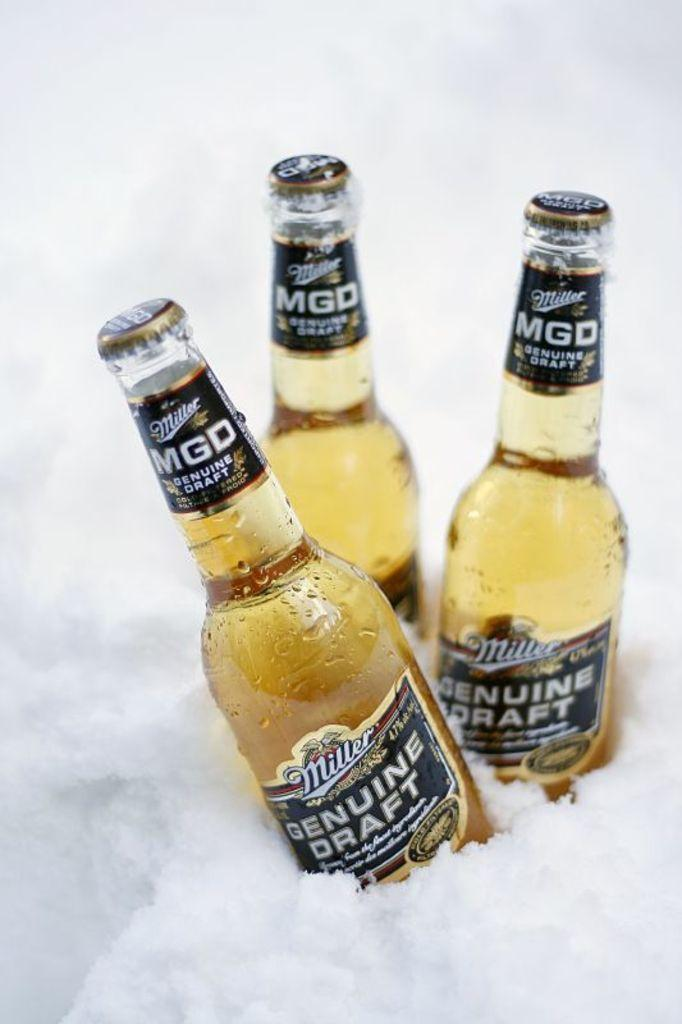<image>
Present a compact description of the photo's key features. three bottles of miller mgd genuine draft standing in ice 